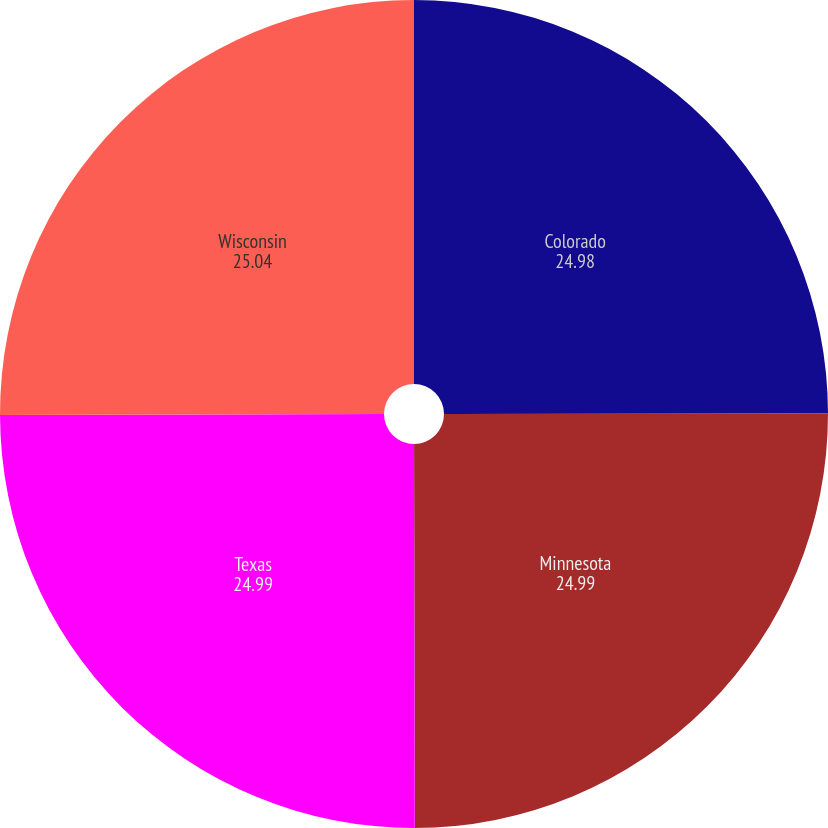<chart> <loc_0><loc_0><loc_500><loc_500><pie_chart><fcel>Colorado<fcel>Minnesota<fcel>Texas<fcel>Wisconsin<nl><fcel>24.98%<fcel>24.99%<fcel>24.99%<fcel>25.04%<nl></chart> 